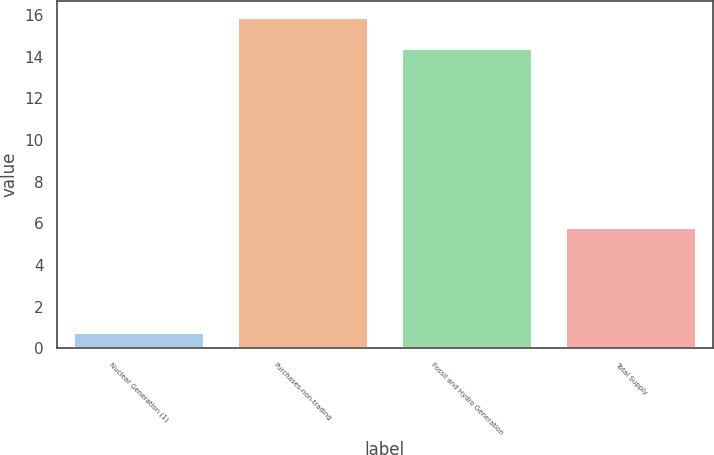<chart> <loc_0><loc_0><loc_500><loc_500><bar_chart><fcel>Nuclear Generation (1)<fcel>Purchases-non-trading<fcel>Fossil and Hydro Generation<fcel>Total Supply<nl><fcel>0.8<fcel>15.9<fcel>14.4<fcel>5.8<nl></chart> 